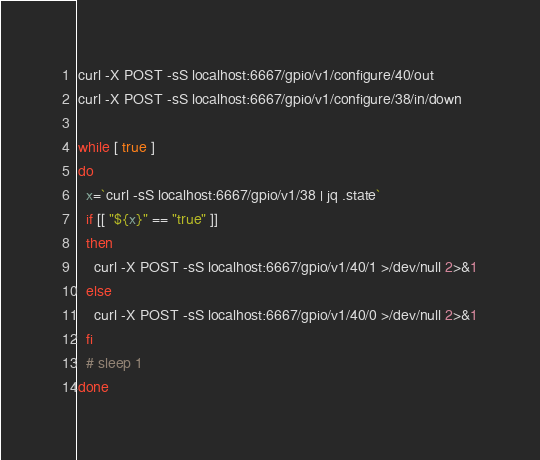Convert code to text. <code><loc_0><loc_0><loc_500><loc_500><_Bash_>
curl -X POST -sS localhost:6667/gpio/v1/configure/40/out
curl -X POST -sS localhost:6667/gpio/v1/configure/38/in/down

while [ true ]
do
  x=`curl -sS localhost:6667/gpio/v1/38 | jq .state`
  if [[ "${x}" == "true" ]]
  then
    curl -X POST -sS localhost:6667/gpio/v1/40/1 >/dev/null 2>&1
  else
    curl -X POST -sS localhost:6667/gpio/v1/40/0 >/dev/null 2>&1
  fi
  # sleep 1
done
</code> 